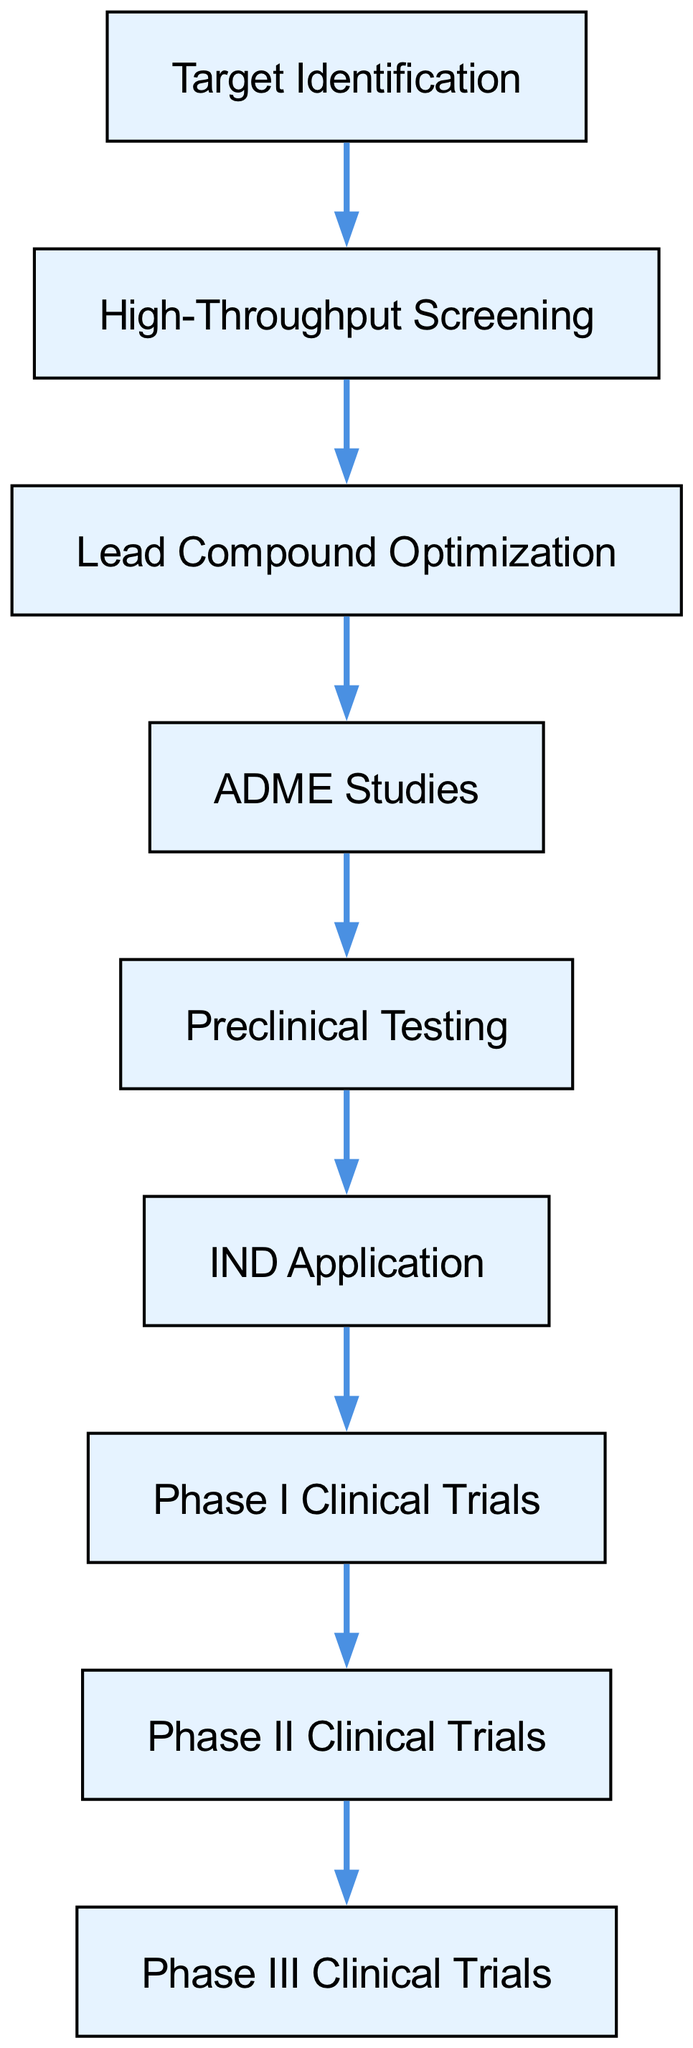What is the first step in the drug discovery process? The first step is labeled in the diagram as "Target Identification", which is the starting point of the flowchart.
Answer: Target Identification How many phases of clinical trials are shown in the diagram? The diagram indicates three phases of clinical trials: Phase I, Phase II, and Phase III, totaling three phases.
Answer: Three What follows after Preclinical Testing? According to the flow of the diagram, the step that follows Preclinical Testing is "IND Application".
Answer: IND Application Which step comes after Lead Compound Optimization? The diagram shows that "ADME Studies" directly follows "Lead Compound Optimization" as the next step in the sequence.
Answer: ADME Studies What is the relationship between High-Throughput Screening and Phase I Clinical Trials? The relationship is that High-Throughput Screening is an earlier step, and it leads sequentially to Phase I Clinical Trials through multiple intermediary processes in the drug discovery flow.
Answer: Sequential relationship How many total steps are there from Target Identification to Phase III Clinical Trials? By counting each step from the diagram starting from Target Identification to the last step Phase III Clinical Trials, there are a total of nine steps.
Answer: Nine Which step directly precedes IND Application? The step that directly comes before IND Application is "Preclinical Testing" in the sequence outlined in the diagram.
Answer: Preclinical Testing After Phase II Clinical Trials, which step follows? The diagram indicates that after Phase II Clinical Trials, the next step is "Phase III Clinical Trials", completing the flow of clinical phases.
Answer: Phase III Clinical Trials What is the last step in the drug discovery process shown in the diagram? The final step listed in the diagram is "Phase III Clinical Trials", which is the conclusive stage represented in the flowchart.
Answer: Phase III Clinical Trials 